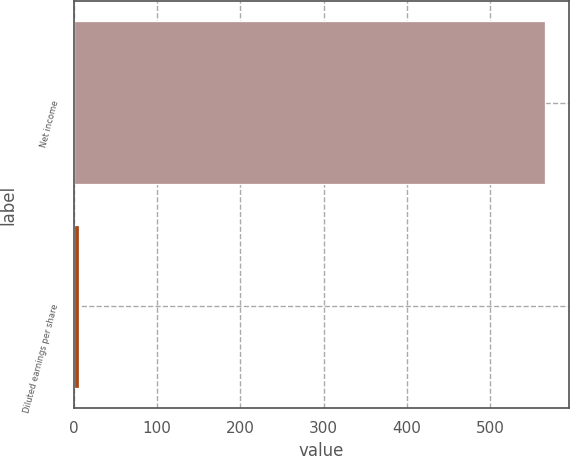Convert chart to OTSL. <chart><loc_0><loc_0><loc_500><loc_500><bar_chart><fcel>Net income<fcel>Diluted earnings per share<nl><fcel>566<fcel>6.45<nl></chart> 